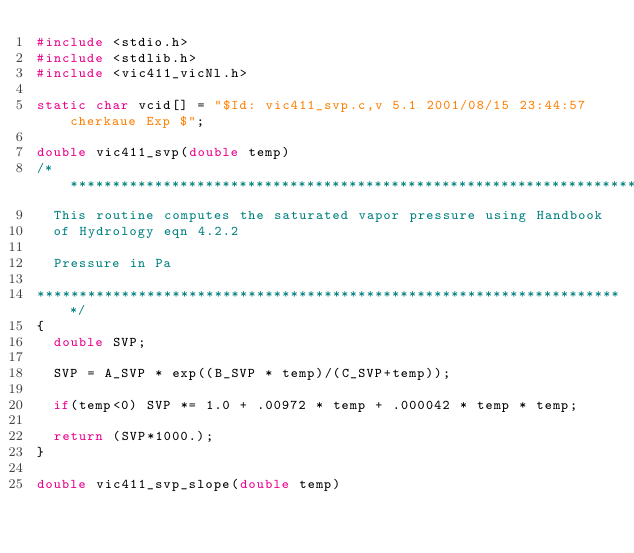<code> <loc_0><loc_0><loc_500><loc_500><_C_>#include <stdio.h>
#include <stdlib.h>
#include <vic411_vicNl.h>

static char vcid[] = "$Id: vic411_svp.c,v 5.1 2001/08/15 23:44:57 cherkaue Exp $";

double vic411_svp(double temp)
/**********************************************************************
  This routine computes the saturated vapor pressure using Handbook
  of Hydrology eqn 4.2.2

  Pressure in Pa

**********************************************************************/
{
  double SVP;
  
  SVP = A_SVP * exp((B_SVP * temp)/(C_SVP+temp));

  if(temp<0) SVP *= 1.0 + .00972 * temp + .000042 * temp * temp;

  return (SVP*1000.);
}

double vic411_svp_slope(double temp)</code> 